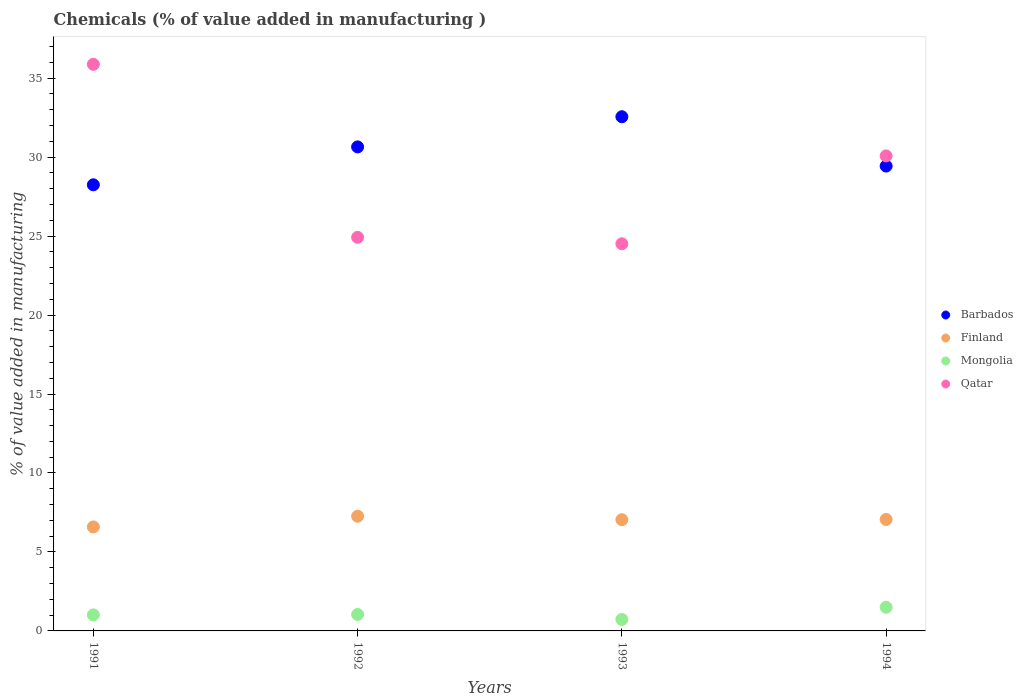How many different coloured dotlines are there?
Keep it short and to the point. 4. Is the number of dotlines equal to the number of legend labels?
Your answer should be compact. Yes. What is the value added in manufacturing chemicals in Barbados in 1993?
Your answer should be very brief. 32.56. Across all years, what is the maximum value added in manufacturing chemicals in Finland?
Ensure brevity in your answer.  7.26. Across all years, what is the minimum value added in manufacturing chemicals in Mongolia?
Provide a short and direct response. 0.72. In which year was the value added in manufacturing chemicals in Finland minimum?
Give a very brief answer. 1991. What is the total value added in manufacturing chemicals in Finland in the graph?
Ensure brevity in your answer.  27.95. What is the difference between the value added in manufacturing chemicals in Finland in 1991 and that in 1992?
Provide a succinct answer. -0.68. What is the difference between the value added in manufacturing chemicals in Finland in 1994 and the value added in manufacturing chemicals in Mongolia in 1992?
Provide a short and direct response. 6.01. What is the average value added in manufacturing chemicals in Mongolia per year?
Make the answer very short. 1.07. In the year 1992, what is the difference between the value added in manufacturing chemicals in Finland and value added in manufacturing chemicals in Barbados?
Offer a very short reply. -23.38. What is the ratio of the value added in manufacturing chemicals in Barbados in 1991 to that in 1994?
Ensure brevity in your answer.  0.96. Is the value added in manufacturing chemicals in Mongolia in 1992 less than that in 1993?
Provide a succinct answer. No. Is the difference between the value added in manufacturing chemicals in Finland in 1992 and 1994 greater than the difference between the value added in manufacturing chemicals in Barbados in 1992 and 1994?
Offer a terse response. No. What is the difference between the highest and the second highest value added in manufacturing chemicals in Finland?
Offer a very short reply. 0.21. What is the difference between the highest and the lowest value added in manufacturing chemicals in Finland?
Your response must be concise. 0.68. Is the sum of the value added in manufacturing chemicals in Finland in 1992 and 1993 greater than the maximum value added in manufacturing chemicals in Barbados across all years?
Provide a short and direct response. No. Is the value added in manufacturing chemicals in Finland strictly less than the value added in manufacturing chemicals in Qatar over the years?
Provide a short and direct response. Yes. What is the difference between two consecutive major ticks on the Y-axis?
Give a very brief answer. 5. Does the graph contain grids?
Keep it short and to the point. No. How many legend labels are there?
Offer a terse response. 4. What is the title of the graph?
Keep it short and to the point. Chemicals (% of value added in manufacturing ). Does "Israel" appear as one of the legend labels in the graph?
Your answer should be compact. No. What is the label or title of the Y-axis?
Provide a succinct answer. % of value added in manufacturing. What is the % of value added in manufacturing of Barbados in 1991?
Make the answer very short. 28.25. What is the % of value added in manufacturing in Finland in 1991?
Your response must be concise. 6.59. What is the % of value added in manufacturing of Mongolia in 1991?
Provide a short and direct response. 1.02. What is the % of value added in manufacturing in Qatar in 1991?
Keep it short and to the point. 35.88. What is the % of value added in manufacturing in Barbados in 1992?
Ensure brevity in your answer.  30.65. What is the % of value added in manufacturing of Finland in 1992?
Make the answer very short. 7.26. What is the % of value added in manufacturing in Mongolia in 1992?
Provide a succinct answer. 1.04. What is the % of value added in manufacturing in Qatar in 1992?
Your response must be concise. 24.92. What is the % of value added in manufacturing of Barbados in 1993?
Your answer should be very brief. 32.56. What is the % of value added in manufacturing in Finland in 1993?
Make the answer very short. 7.04. What is the % of value added in manufacturing of Mongolia in 1993?
Your answer should be very brief. 0.72. What is the % of value added in manufacturing in Qatar in 1993?
Offer a very short reply. 24.51. What is the % of value added in manufacturing of Barbados in 1994?
Offer a terse response. 29.43. What is the % of value added in manufacturing of Finland in 1994?
Give a very brief answer. 7.06. What is the % of value added in manufacturing in Mongolia in 1994?
Make the answer very short. 1.5. What is the % of value added in manufacturing of Qatar in 1994?
Your answer should be compact. 30.08. Across all years, what is the maximum % of value added in manufacturing of Barbados?
Your response must be concise. 32.56. Across all years, what is the maximum % of value added in manufacturing of Finland?
Offer a very short reply. 7.26. Across all years, what is the maximum % of value added in manufacturing in Mongolia?
Provide a short and direct response. 1.5. Across all years, what is the maximum % of value added in manufacturing of Qatar?
Provide a succinct answer. 35.88. Across all years, what is the minimum % of value added in manufacturing of Barbados?
Your answer should be very brief. 28.25. Across all years, what is the minimum % of value added in manufacturing in Finland?
Your response must be concise. 6.59. Across all years, what is the minimum % of value added in manufacturing of Mongolia?
Give a very brief answer. 0.72. Across all years, what is the minimum % of value added in manufacturing in Qatar?
Give a very brief answer. 24.51. What is the total % of value added in manufacturing in Barbados in the graph?
Keep it short and to the point. 120.89. What is the total % of value added in manufacturing of Finland in the graph?
Make the answer very short. 27.95. What is the total % of value added in manufacturing of Mongolia in the graph?
Ensure brevity in your answer.  4.28. What is the total % of value added in manufacturing of Qatar in the graph?
Your answer should be compact. 115.39. What is the difference between the % of value added in manufacturing in Barbados in 1991 and that in 1992?
Your answer should be very brief. -2.4. What is the difference between the % of value added in manufacturing of Finland in 1991 and that in 1992?
Offer a very short reply. -0.68. What is the difference between the % of value added in manufacturing of Mongolia in 1991 and that in 1992?
Your answer should be very brief. -0.03. What is the difference between the % of value added in manufacturing in Qatar in 1991 and that in 1992?
Offer a very short reply. 10.95. What is the difference between the % of value added in manufacturing in Barbados in 1991 and that in 1993?
Provide a succinct answer. -4.31. What is the difference between the % of value added in manufacturing in Finland in 1991 and that in 1993?
Your answer should be very brief. -0.46. What is the difference between the % of value added in manufacturing in Mongolia in 1991 and that in 1993?
Your answer should be compact. 0.29. What is the difference between the % of value added in manufacturing of Qatar in 1991 and that in 1993?
Give a very brief answer. 11.36. What is the difference between the % of value added in manufacturing of Barbados in 1991 and that in 1994?
Your answer should be very brief. -1.19. What is the difference between the % of value added in manufacturing of Finland in 1991 and that in 1994?
Ensure brevity in your answer.  -0.47. What is the difference between the % of value added in manufacturing of Mongolia in 1991 and that in 1994?
Your response must be concise. -0.48. What is the difference between the % of value added in manufacturing in Qatar in 1991 and that in 1994?
Give a very brief answer. 5.8. What is the difference between the % of value added in manufacturing in Barbados in 1992 and that in 1993?
Offer a terse response. -1.91. What is the difference between the % of value added in manufacturing in Finland in 1992 and that in 1993?
Your response must be concise. 0.22. What is the difference between the % of value added in manufacturing in Mongolia in 1992 and that in 1993?
Your answer should be compact. 0.32. What is the difference between the % of value added in manufacturing in Qatar in 1992 and that in 1993?
Offer a very short reply. 0.41. What is the difference between the % of value added in manufacturing of Barbados in 1992 and that in 1994?
Provide a succinct answer. 1.21. What is the difference between the % of value added in manufacturing of Finland in 1992 and that in 1994?
Provide a short and direct response. 0.21. What is the difference between the % of value added in manufacturing of Mongolia in 1992 and that in 1994?
Offer a very short reply. -0.45. What is the difference between the % of value added in manufacturing in Qatar in 1992 and that in 1994?
Provide a succinct answer. -5.16. What is the difference between the % of value added in manufacturing in Barbados in 1993 and that in 1994?
Offer a terse response. 3.12. What is the difference between the % of value added in manufacturing of Finland in 1993 and that in 1994?
Your response must be concise. -0.02. What is the difference between the % of value added in manufacturing in Mongolia in 1993 and that in 1994?
Keep it short and to the point. -0.77. What is the difference between the % of value added in manufacturing in Qatar in 1993 and that in 1994?
Your answer should be very brief. -5.56. What is the difference between the % of value added in manufacturing in Barbados in 1991 and the % of value added in manufacturing in Finland in 1992?
Your response must be concise. 20.98. What is the difference between the % of value added in manufacturing of Barbados in 1991 and the % of value added in manufacturing of Mongolia in 1992?
Provide a succinct answer. 27.21. What is the difference between the % of value added in manufacturing of Barbados in 1991 and the % of value added in manufacturing of Qatar in 1992?
Give a very brief answer. 3.33. What is the difference between the % of value added in manufacturing in Finland in 1991 and the % of value added in manufacturing in Mongolia in 1992?
Your answer should be compact. 5.54. What is the difference between the % of value added in manufacturing in Finland in 1991 and the % of value added in manufacturing in Qatar in 1992?
Offer a very short reply. -18.34. What is the difference between the % of value added in manufacturing in Mongolia in 1991 and the % of value added in manufacturing in Qatar in 1992?
Ensure brevity in your answer.  -23.91. What is the difference between the % of value added in manufacturing of Barbados in 1991 and the % of value added in manufacturing of Finland in 1993?
Give a very brief answer. 21.21. What is the difference between the % of value added in manufacturing in Barbados in 1991 and the % of value added in manufacturing in Mongolia in 1993?
Ensure brevity in your answer.  27.52. What is the difference between the % of value added in manufacturing of Barbados in 1991 and the % of value added in manufacturing of Qatar in 1993?
Make the answer very short. 3.73. What is the difference between the % of value added in manufacturing of Finland in 1991 and the % of value added in manufacturing of Mongolia in 1993?
Offer a terse response. 5.86. What is the difference between the % of value added in manufacturing of Finland in 1991 and the % of value added in manufacturing of Qatar in 1993?
Make the answer very short. -17.93. What is the difference between the % of value added in manufacturing in Mongolia in 1991 and the % of value added in manufacturing in Qatar in 1993?
Offer a terse response. -23.5. What is the difference between the % of value added in manufacturing of Barbados in 1991 and the % of value added in manufacturing of Finland in 1994?
Your response must be concise. 21.19. What is the difference between the % of value added in manufacturing in Barbados in 1991 and the % of value added in manufacturing in Mongolia in 1994?
Your response must be concise. 26.75. What is the difference between the % of value added in manufacturing of Barbados in 1991 and the % of value added in manufacturing of Qatar in 1994?
Offer a terse response. -1.83. What is the difference between the % of value added in manufacturing in Finland in 1991 and the % of value added in manufacturing in Mongolia in 1994?
Your response must be concise. 5.09. What is the difference between the % of value added in manufacturing of Finland in 1991 and the % of value added in manufacturing of Qatar in 1994?
Ensure brevity in your answer.  -23.49. What is the difference between the % of value added in manufacturing in Mongolia in 1991 and the % of value added in manufacturing in Qatar in 1994?
Give a very brief answer. -29.06. What is the difference between the % of value added in manufacturing in Barbados in 1992 and the % of value added in manufacturing in Finland in 1993?
Give a very brief answer. 23.61. What is the difference between the % of value added in manufacturing in Barbados in 1992 and the % of value added in manufacturing in Mongolia in 1993?
Provide a short and direct response. 29.92. What is the difference between the % of value added in manufacturing of Barbados in 1992 and the % of value added in manufacturing of Qatar in 1993?
Offer a terse response. 6.13. What is the difference between the % of value added in manufacturing of Finland in 1992 and the % of value added in manufacturing of Mongolia in 1993?
Your answer should be compact. 6.54. What is the difference between the % of value added in manufacturing of Finland in 1992 and the % of value added in manufacturing of Qatar in 1993?
Your answer should be very brief. -17.25. What is the difference between the % of value added in manufacturing in Mongolia in 1992 and the % of value added in manufacturing in Qatar in 1993?
Ensure brevity in your answer.  -23.47. What is the difference between the % of value added in manufacturing in Barbados in 1992 and the % of value added in manufacturing in Finland in 1994?
Your answer should be very brief. 23.59. What is the difference between the % of value added in manufacturing of Barbados in 1992 and the % of value added in manufacturing of Mongolia in 1994?
Your answer should be very brief. 29.15. What is the difference between the % of value added in manufacturing of Barbados in 1992 and the % of value added in manufacturing of Qatar in 1994?
Your answer should be very brief. 0.57. What is the difference between the % of value added in manufacturing in Finland in 1992 and the % of value added in manufacturing in Mongolia in 1994?
Ensure brevity in your answer.  5.77. What is the difference between the % of value added in manufacturing of Finland in 1992 and the % of value added in manufacturing of Qatar in 1994?
Offer a terse response. -22.81. What is the difference between the % of value added in manufacturing of Mongolia in 1992 and the % of value added in manufacturing of Qatar in 1994?
Offer a very short reply. -29.04. What is the difference between the % of value added in manufacturing of Barbados in 1993 and the % of value added in manufacturing of Finland in 1994?
Offer a very short reply. 25.5. What is the difference between the % of value added in manufacturing of Barbados in 1993 and the % of value added in manufacturing of Mongolia in 1994?
Offer a terse response. 31.06. What is the difference between the % of value added in manufacturing of Barbados in 1993 and the % of value added in manufacturing of Qatar in 1994?
Provide a succinct answer. 2.48. What is the difference between the % of value added in manufacturing in Finland in 1993 and the % of value added in manufacturing in Mongolia in 1994?
Your answer should be very brief. 5.54. What is the difference between the % of value added in manufacturing of Finland in 1993 and the % of value added in manufacturing of Qatar in 1994?
Ensure brevity in your answer.  -23.04. What is the difference between the % of value added in manufacturing of Mongolia in 1993 and the % of value added in manufacturing of Qatar in 1994?
Keep it short and to the point. -29.35. What is the average % of value added in manufacturing in Barbados per year?
Give a very brief answer. 30.22. What is the average % of value added in manufacturing of Finland per year?
Your answer should be compact. 6.99. What is the average % of value added in manufacturing of Mongolia per year?
Ensure brevity in your answer.  1.07. What is the average % of value added in manufacturing in Qatar per year?
Keep it short and to the point. 28.85. In the year 1991, what is the difference between the % of value added in manufacturing of Barbados and % of value added in manufacturing of Finland?
Provide a short and direct response. 21.66. In the year 1991, what is the difference between the % of value added in manufacturing in Barbados and % of value added in manufacturing in Mongolia?
Make the answer very short. 27.23. In the year 1991, what is the difference between the % of value added in manufacturing of Barbados and % of value added in manufacturing of Qatar?
Make the answer very short. -7.63. In the year 1991, what is the difference between the % of value added in manufacturing of Finland and % of value added in manufacturing of Mongolia?
Ensure brevity in your answer.  5.57. In the year 1991, what is the difference between the % of value added in manufacturing of Finland and % of value added in manufacturing of Qatar?
Make the answer very short. -29.29. In the year 1991, what is the difference between the % of value added in manufacturing of Mongolia and % of value added in manufacturing of Qatar?
Your response must be concise. -34.86. In the year 1992, what is the difference between the % of value added in manufacturing in Barbados and % of value added in manufacturing in Finland?
Offer a very short reply. 23.38. In the year 1992, what is the difference between the % of value added in manufacturing of Barbados and % of value added in manufacturing of Mongolia?
Provide a succinct answer. 29.6. In the year 1992, what is the difference between the % of value added in manufacturing in Barbados and % of value added in manufacturing in Qatar?
Your answer should be compact. 5.72. In the year 1992, what is the difference between the % of value added in manufacturing of Finland and % of value added in manufacturing of Mongolia?
Provide a short and direct response. 6.22. In the year 1992, what is the difference between the % of value added in manufacturing in Finland and % of value added in manufacturing in Qatar?
Your answer should be very brief. -17.66. In the year 1992, what is the difference between the % of value added in manufacturing in Mongolia and % of value added in manufacturing in Qatar?
Your response must be concise. -23.88. In the year 1993, what is the difference between the % of value added in manufacturing in Barbados and % of value added in manufacturing in Finland?
Provide a succinct answer. 25.52. In the year 1993, what is the difference between the % of value added in manufacturing in Barbados and % of value added in manufacturing in Mongolia?
Provide a short and direct response. 31.83. In the year 1993, what is the difference between the % of value added in manufacturing in Barbados and % of value added in manufacturing in Qatar?
Offer a very short reply. 8.04. In the year 1993, what is the difference between the % of value added in manufacturing in Finland and % of value added in manufacturing in Mongolia?
Provide a succinct answer. 6.32. In the year 1993, what is the difference between the % of value added in manufacturing of Finland and % of value added in manufacturing of Qatar?
Ensure brevity in your answer.  -17.47. In the year 1993, what is the difference between the % of value added in manufacturing of Mongolia and % of value added in manufacturing of Qatar?
Your response must be concise. -23.79. In the year 1994, what is the difference between the % of value added in manufacturing of Barbados and % of value added in manufacturing of Finland?
Offer a very short reply. 22.38. In the year 1994, what is the difference between the % of value added in manufacturing in Barbados and % of value added in manufacturing in Mongolia?
Offer a very short reply. 27.94. In the year 1994, what is the difference between the % of value added in manufacturing in Barbados and % of value added in manufacturing in Qatar?
Ensure brevity in your answer.  -0.64. In the year 1994, what is the difference between the % of value added in manufacturing in Finland and % of value added in manufacturing in Mongolia?
Your response must be concise. 5.56. In the year 1994, what is the difference between the % of value added in manufacturing in Finland and % of value added in manufacturing in Qatar?
Provide a short and direct response. -23.02. In the year 1994, what is the difference between the % of value added in manufacturing in Mongolia and % of value added in manufacturing in Qatar?
Provide a short and direct response. -28.58. What is the ratio of the % of value added in manufacturing in Barbados in 1991 to that in 1992?
Your response must be concise. 0.92. What is the ratio of the % of value added in manufacturing of Finland in 1991 to that in 1992?
Ensure brevity in your answer.  0.91. What is the ratio of the % of value added in manufacturing in Mongolia in 1991 to that in 1992?
Ensure brevity in your answer.  0.97. What is the ratio of the % of value added in manufacturing of Qatar in 1991 to that in 1992?
Offer a very short reply. 1.44. What is the ratio of the % of value added in manufacturing in Barbados in 1991 to that in 1993?
Ensure brevity in your answer.  0.87. What is the ratio of the % of value added in manufacturing of Finland in 1991 to that in 1993?
Your answer should be very brief. 0.94. What is the ratio of the % of value added in manufacturing of Mongolia in 1991 to that in 1993?
Give a very brief answer. 1.4. What is the ratio of the % of value added in manufacturing in Qatar in 1991 to that in 1993?
Ensure brevity in your answer.  1.46. What is the ratio of the % of value added in manufacturing in Barbados in 1991 to that in 1994?
Make the answer very short. 0.96. What is the ratio of the % of value added in manufacturing in Finland in 1991 to that in 1994?
Provide a succinct answer. 0.93. What is the ratio of the % of value added in manufacturing in Mongolia in 1991 to that in 1994?
Offer a terse response. 0.68. What is the ratio of the % of value added in manufacturing of Qatar in 1991 to that in 1994?
Keep it short and to the point. 1.19. What is the ratio of the % of value added in manufacturing of Barbados in 1992 to that in 1993?
Offer a very short reply. 0.94. What is the ratio of the % of value added in manufacturing in Finland in 1992 to that in 1993?
Provide a short and direct response. 1.03. What is the ratio of the % of value added in manufacturing in Mongolia in 1992 to that in 1993?
Your response must be concise. 1.44. What is the ratio of the % of value added in manufacturing of Qatar in 1992 to that in 1993?
Ensure brevity in your answer.  1.02. What is the ratio of the % of value added in manufacturing in Barbados in 1992 to that in 1994?
Offer a terse response. 1.04. What is the ratio of the % of value added in manufacturing in Finland in 1992 to that in 1994?
Keep it short and to the point. 1.03. What is the ratio of the % of value added in manufacturing of Mongolia in 1992 to that in 1994?
Your response must be concise. 0.7. What is the ratio of the % of value added in manufacturing of Qatar in 1992 to that in 1994?
Make the answer very short. 0.83. What is the ratio of the % of value added in manufacturing in Barbados in 1993 to that in 1994?
Provide a short and direct response. 1.11. What is the ratio of the % of value added in manufacturing in Finland in 1993 to that in 1994?
Give a very brief answer. 1. What is the ratio of the % of value added in manufacturing in Mongolia in 1993 to that in 1994?
Give a very brief answer. 0.48. What is the ratio of the % of value added in manufacturing in Qatar in 1993 to that in 1994?
Your response must be concise. 0.81. What is the difference between the highest and the second highest % of value added in manufacturing in Barbados?
Offer a terse response. 1.91. What is the difference between the highest and the second highest % of value added in manufacturing in Finland?
Ensure brevity in your answer.  0.21. What is the difference between the highest and the second highest % of value added in manufacturing of Mongolia?
Provide a succinct answer. 0.45. What is the difference between the highest and the second highest % of value added in manufacturing of Qatar?
Your response must be concise. 5.8. What is the difference between the highest and the lowest % of value added in manufacturing in Barbados?
Your answer should be very brief. 4.31. What is the difference between the highest and the lowest % of value added in manufacturing in Finland?
Your answer should be compact. 0.68. What is the difference between the highest and the lowest % of value added in manufacturing in Mongolia?
Provide a short and direct response. 0.77. What is the difference between the highest and the lowest % of value added in manufacturing in Qatar?
Offer a very short reply. 11.36. 